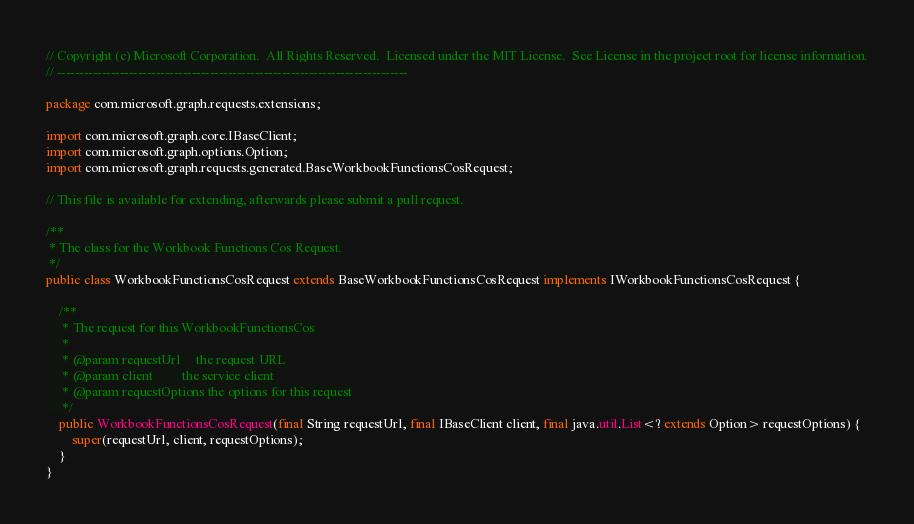<code> <loc_0><loc_0><loc_500><loc_500><_Java_>// Copyright (c) Microsoft Corporation.  All Rights Reserved.  Licensed under the MIT License.  See License in the project root for license information.
// ------------------------------------------------------------------------------

package com.microsoft.graph.requests.extensions;

import com.microsoft.graph.core.IBaseClient;
import com.microsoft.graph.options.Option;
import com.microsoft.graph.requests.generated.BaseWorkbookFunctionsCosRequest;

// This file is available for extending, afterwards please submit a pull request.

/**
 * The class for the Workbook Functions Cos Request.
 */
public class WorkbookFunctionsCosRequest extends BaseWorkbookFunctionsCosRequest implements IWorkbookFunctionsCosRequest {

    /**
     * The request for this WorkbookFunctionsCos
     *
     * @param requestUrl     the request URL
     * @param client         the service client
     * @param requestOptions the options for this request
     */
    public WorkbookFunctionsCosRequest(final String requestUrl, final IBaseClient client, final java.util.List<? extends Option> requestOptions) {
        super(requestUrl, client, requestOptions);
    }
}
</code> 